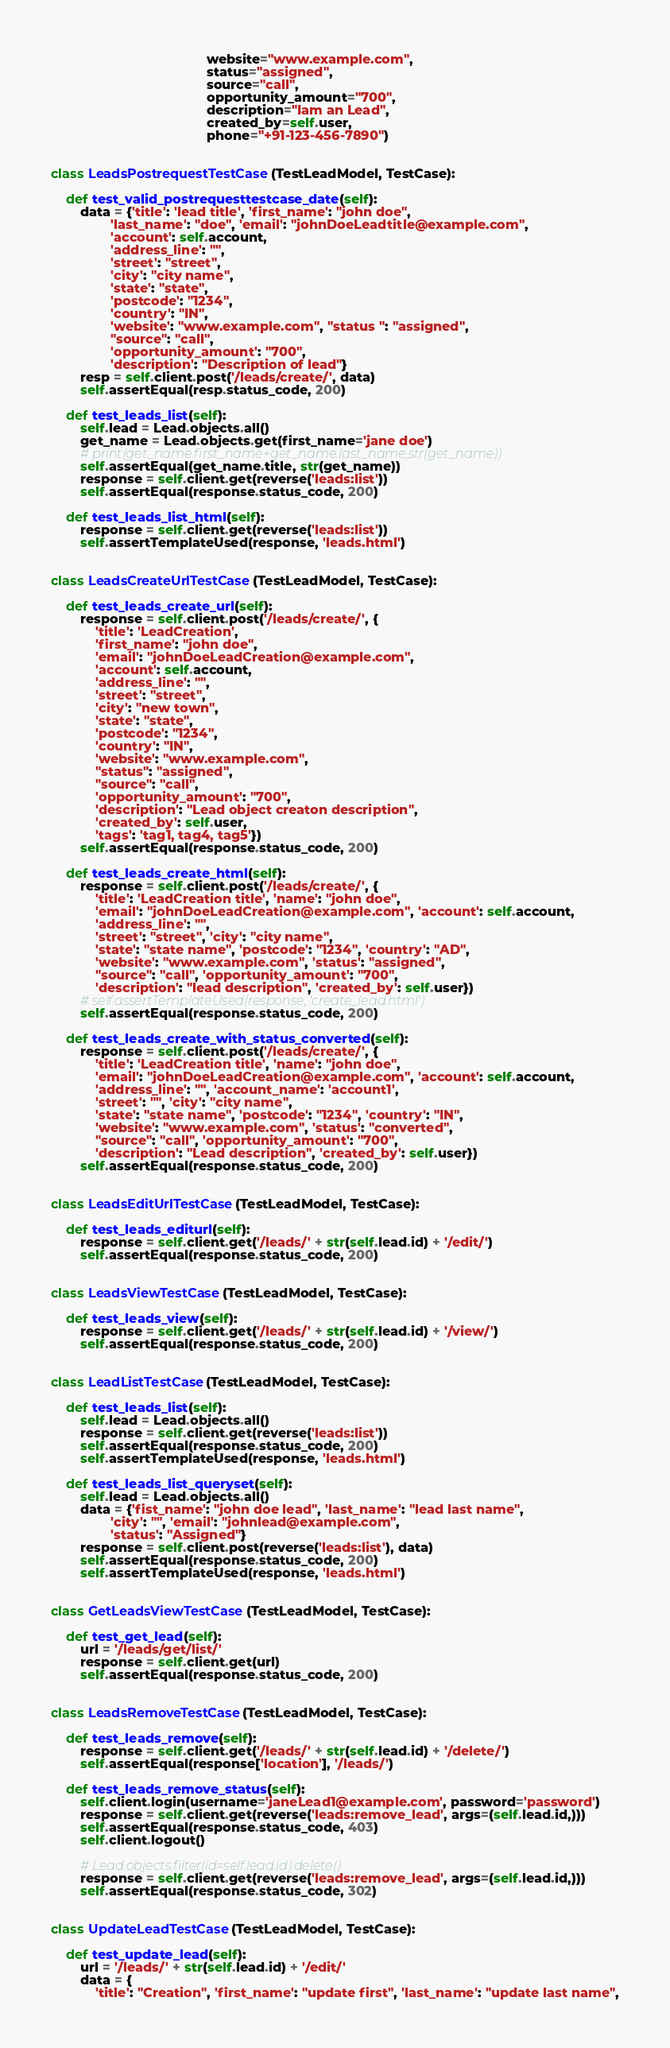<code> <loc_0><loc_0><loc_500><loc_500><_Python_>                                          website="www.example.com",
                                          status="assigned",
                                          source="call",
                                          opportunity_amount="700",
                                          description="Iam an Lead",
                                          created_by=self.user,
                                          phone="+91-123-456-7890")


class LeadsPostrequestTestCase(TestLeadModel, TestCase):

    def test_valid_postrequesttestcase_date(self):
        data = {'title': 'lead title', 'first_name': "john doe",
                'last_name': "doe", 'email': "johnDoeLeadtitle@example.com",
                'account': self.account,
                'address_line': "",
                'street': "street",
                'city': "city name",
                'state': "state",
                'postcode': "1234",
                'country': "IN",
                'website': "www.example.com", "status ": "assigned",
                "source": "call",
                'opportunity_amount': "700",
                'description': "Description of lead"}
        resp = self.client.post('/leads/create/', data)
        self.assertEqual(resp.status_code, 200)

    def test_leads_list(self):
        self.lead = Lead.objects.all()
        get_name = Lead.objects.get(first_name='jane doe')
        # print(get_name.first_name+get_name.last_name,str(get_name))
        self.assertEqual(get_name.title, str(get_name))
        response = self.client.get(reverse('leads:list'))
        self.assertEqual(response.status_code, 200)

    def test_leads_list_html(self):
        response = self.client.get(reverse('leads:list'))
        self.assertTemplateUsed(response, 'leads.html')


class LeadsCreateUrlTestCase(TestLeadModel, TestCase):

    def test_leads_create_url(self):
        response = self.client.post('/leads/create/', {
            'title': 'LeadCreation',
            'first_name': "john doe",
            'email': "johnDoeLeadCreation@example.com",
            'account': self.account,
            'address_line': "",
            'street': "street",
            'city': "new town",
            'state': "state",
            'postcode': "1234",
            'country': "IN",
            'website': "www.example.com",
            "status": "assigned",
            "source": "call",
            'opportunity_amount': "700",
            'description': "Lead object creaton description",
            'created_by': self.user,
            'tags': 'tag1, tag4, tag5'})
        self.assertEqual(response.status_code, 200)

    def test_leads_create_html(self):
        response = self.client.post('/leads/create/', {
            'title': 'LeadCreation title', 'name': "john doe",
            'email': "johnDoeLeadCreation@example.com", 'account': self.account,
            'address_line': "",
            'street': "street", 'city': "city name",
            'state': "state name", 'postcode': "1234", 'country': "AD",
            'website': "www.example.com", 'status': "assigned",
            "source": "call", 'opportunity_amount': "700",
            'description': "lead description", 'created_by': self.user})
        # self.assertTemplateUsed(response, 'create_lead.html')
        self.assertEqual(response.status_code, 200)

    def test_leads_create_with_status_converted(self):
        response = self.client.post('/leads/create/', {
            'title': 'LeadCreation title', 'name': "john doe",
            'email': "johnDoeLeadCreation@example.com", 'account': self.account,
            'address_line': "", 'account_name': 'account1',
            'street': "", 'city': "city name",
            'state': "state name", 'postcode': "1234", 'country': "IN",
            'website': "www.example.com", 'status': "converted",
            "source": "call", 'opportunity_amount': "700",
            'description': "Lead description", 'created_by': self.user})
        self.assertEqual(response.status_code, 200)


class LeadsEditUrlTestCase(TestLeadModel, TestCase):

    def test_leads_editurl(self):
        response = self.client.get('/leads/' + str(self.lead.id) + '/edit/')
        self.assertEqual(response.status_code, 200)


class LeadsViewTestCase(TestLeadModel, TestCase):

    def test_leads_view(self):
        response = self.client.get('/leads/' + str(self.lead.id) + '/view/')
        self.assertEqual(response.status_code, 200)


class LeadListTestCase(TestLeadModel, TestCase):

    def test_leads_list(self):
        self.lead = Lead.objects.all()
        response = self.client.get(reverse('leads:list'))
        self.assertEqual(response.status_code, 200)
        self.assertTemplateUsed(response, 'leads.html')

    def test_leads_list_queryset(self):
        self.lead = Lead.objects.all()
        data = {'fist_name': "john doe lead", 'last_name': "lead last name",
                'city': "", 'email': "johnlead@example.com",
                'status': "Assigned"}
        response = self.client.post(reverse('leads:list'), data)
        self.assertEqual(response.status_code, 200)
        self.assertTemplateUsed(response, 'leads.html')


class GetLeadsViewTestCase(TestLeadModel, TestCase):

    def test_get_lead(self):
        url = '/leads/get/list/'
        response = self.client.get(url)
        self.assertEqual(response.status_code, 200)


class LeadsRemoveTestCase(TestLeadModel, TestCase):

    def test_leads_remove(self):
        response = self.client.get('/leads/' + str(self.lead.id) + '/delete/')
        self.assertEqual(response['location'], '/leads/')

    def test_leads_remove_status(self):
        self.client.login(username='janeLead1@example.com', password='password')
        response = self.client.get(reverse('leads:remove_lead', args=(self.lead.id,)))
        self.assertEqual(response.status_code, 403)
        self.client.logout()

        # Lead.objects.filter(id=self.lead.id).delete()
        response = self.client.get(reverse('leads:remove_lead', args=(self.lead.id,)))
        self.assertEqual(response.status_code, 302)


class UpdateLeadTestCase(TestLeadModel, TestCase):

    def test_update_lead(self):
        url = '/leads/' + str(self.lead.id) + '/edit/'
        data = {
            'title': "Creation", 'first_name': "update first", 'last_name': "update last name",</code> 